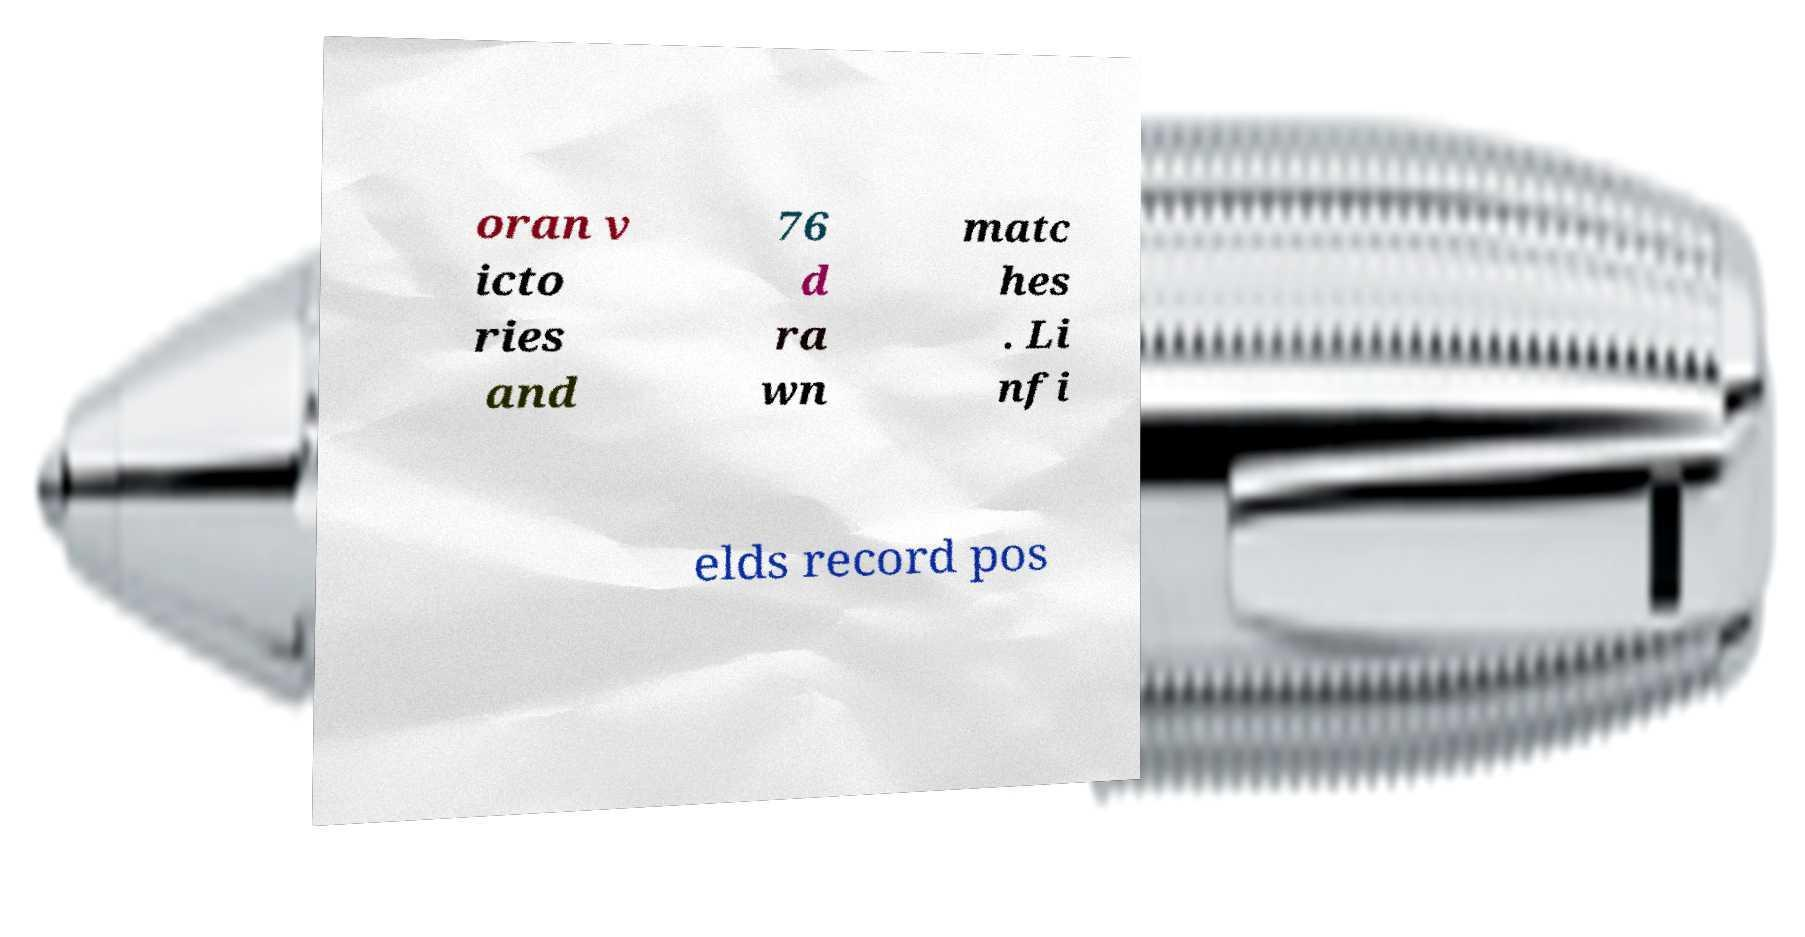Please identify and transcribe the text found in this image. oran v icto ries and 76 d ra wn matc hes . Li nfi elds record pos 